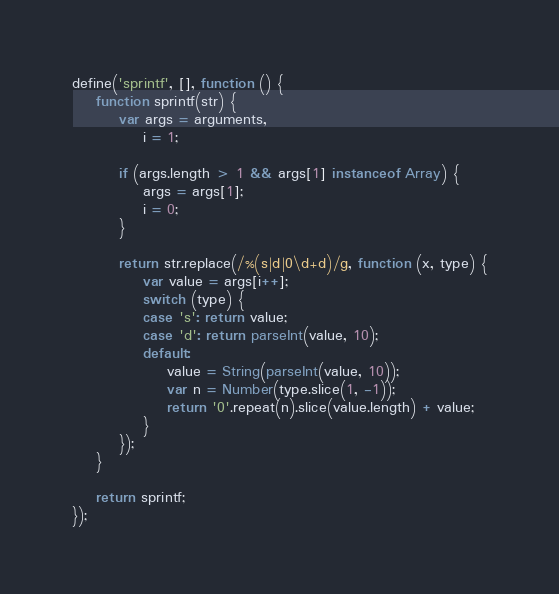Convert code to text. <code><loc_0><loc_0><loc_500><loc_500><_JavaScript_>define('sprintf', [], function () {
	function sprintf(str) {
		var args = arguments,
			i = 1;

		if (args.length > 1 && args[1] instanceof Array) {
			args = args[1];
			i = 0;
		}

		return str.replace(/%(s|d|0\d+d)/g, function (x, type) {
			var value = args[i++];
			switch (type) {
			case 's': return value;
			case 'd': return parseInt(value, 10);
			default:
				value = String(parseInt(value, 10));
				var n = Number(type.slice(1, -1));
				return '0'.repeat(n).slice(value.length) + value;
			}
		});
	}

	return sprintf;
});</code> 